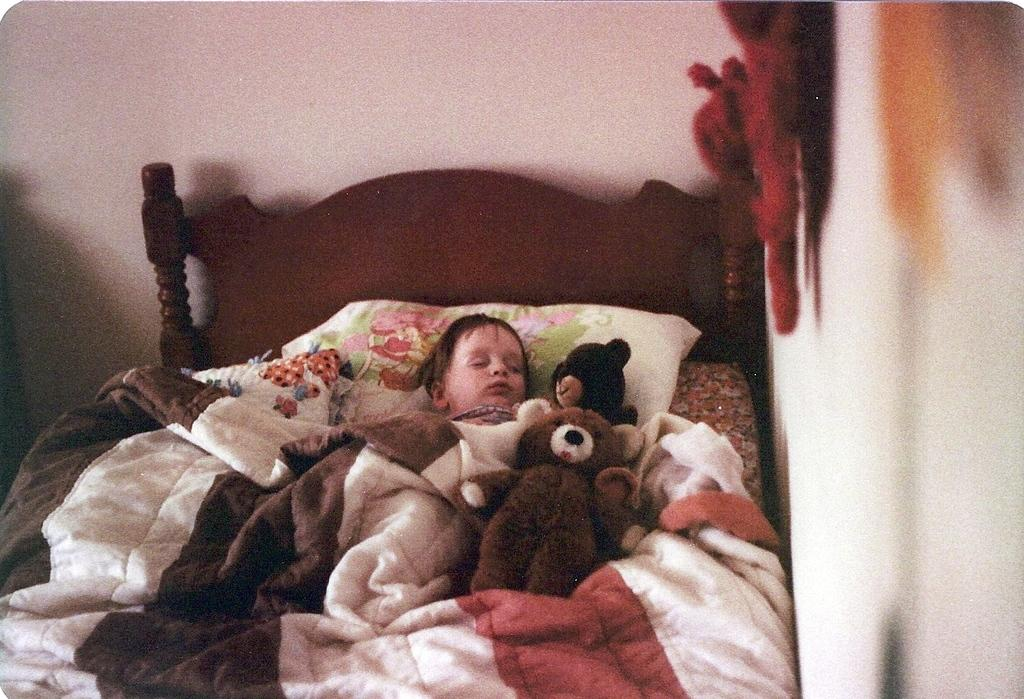What is the main subject of the image? There is a baby in the image. What is the baby doing in the image? The baby is sleeping on a bed. What is supporting the baby's head while they sleep? There is a pillow under the baby. What is covering the baby to keep them warm? The baby has a blanket on them. What type of toys are present in the image? There are teddy bears beside the baby. How does the baby compare the different types of vests in the image? There are no vests present in the image, and the baby is sleeping, so they cannot be comparing anything. 